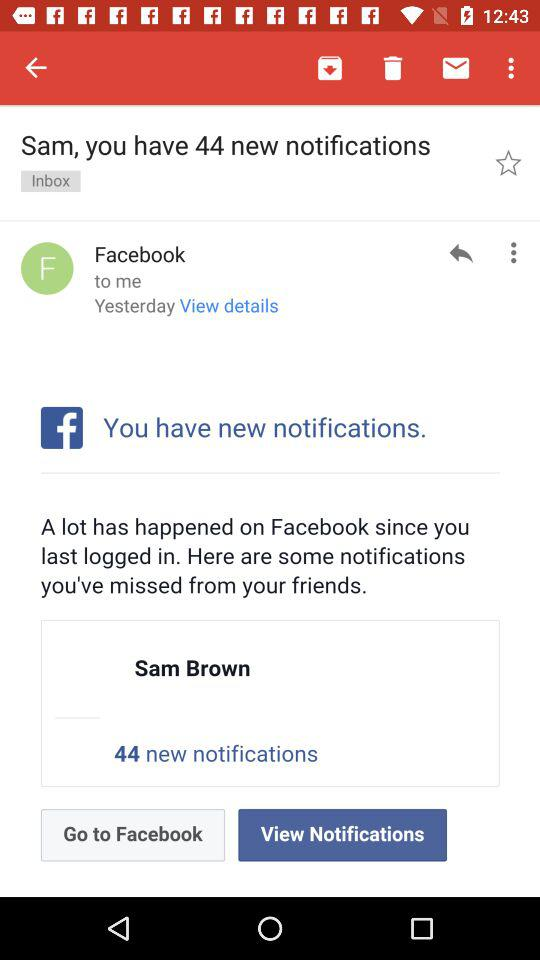How many more notifications do I have than Facebook messages?
Answer the question using a single word or phrase. 44 